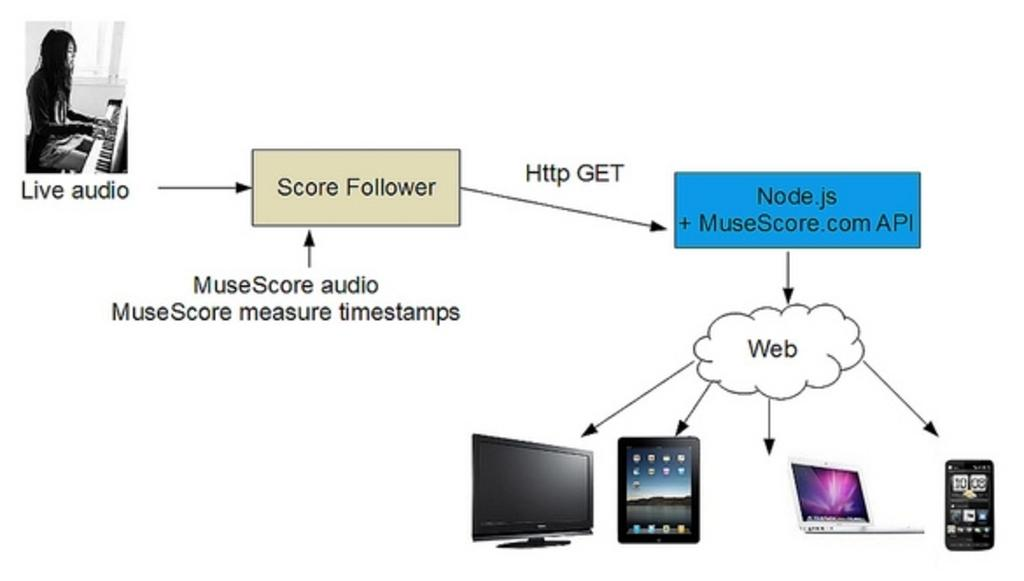Provide a one-sentence caption for the provided image. A diagram provides information about how the MuseScore music program works. 